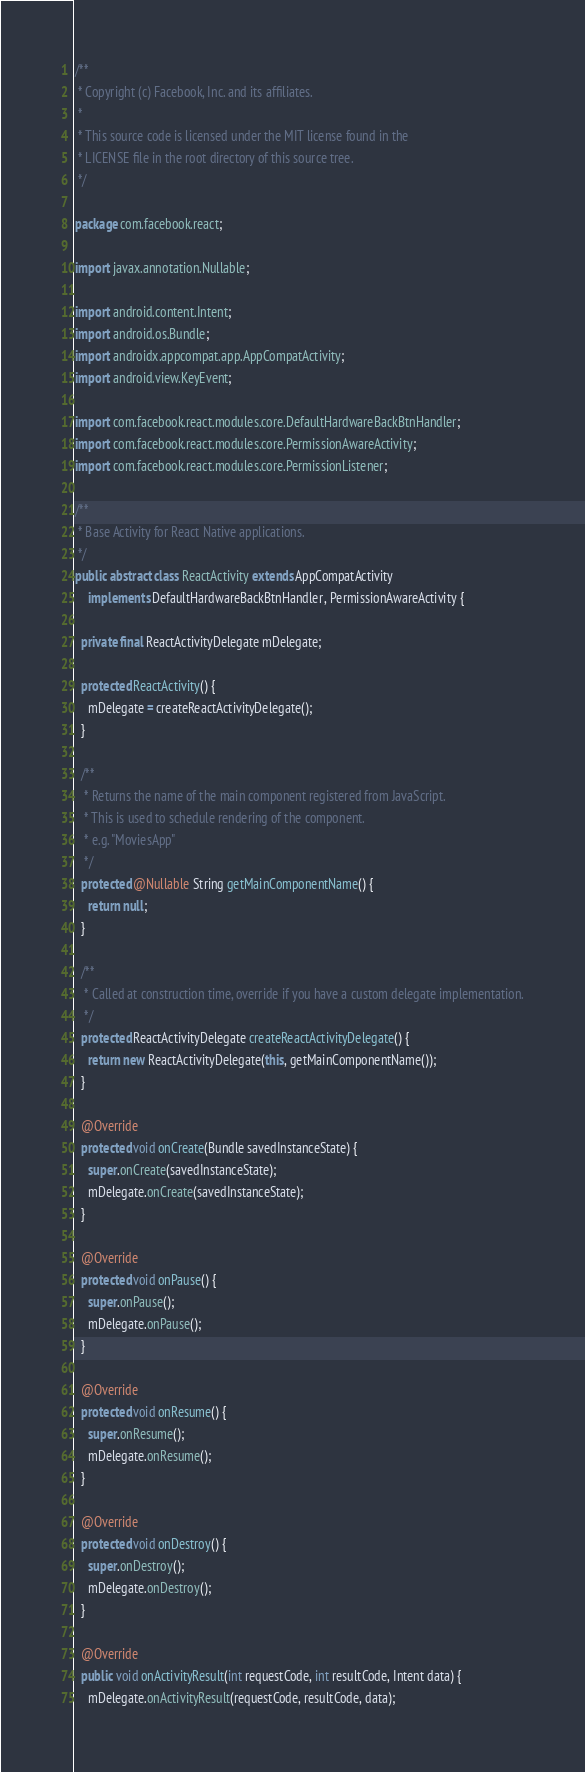<code> <loc_0><loc_0><loc_500><loc_500><_Java_>/**
 * Copyright (c) Facebook, Inc. and its affiliates.
 *
 * This source code is licensed under the MIT license found in the
 * LICENSE file in the root directory of this source tree.
 */

package com.facebook.react;

import javax.annotation.Nullable;

import android.content.Intent;
import android.os.Bundle;
import androidx.appcompat.app.AppCompatActivity;
import android.view.KeyEvent;

import com.facebook.react.modules.core.DefaultHardwareBackBtnHandler;
import com.facebook.react.modules.core.PermissionAwareActivity;
import com.facebook.react.modules.core.PermissionListener;

/**
 * Base Activity for React Native applications.
 */
public abstract class ReactActivity extends AppCompatActivity
    implements DefaultHardwareBackBtnHandler, PermissionAwareActivity {

  private final ReactActivityDelegate mDelegate;

  protected ReactActivity() {
    mDelegate = createReactActivityDelegate();
  }

  /**
   * Returns the name of the main component registered from JavaScript.
   * This is used to schedule rendering of the component.
   * e.g. "MoviesApp"
   */
  protected @Nullable String getMainComponentName() {
    return null;
  }

  /**
   * Called at construction time, override if you have a custom delegate implementation.
   */
  protected ReactActivityDelegate createReactActivityDelegate() {
    return new ReactActivityDelegate(this, getMainComponentName());
  }

  @Override
  protected void onCreate(Bundle savedInstanceState) {
    super.onCreate(savedInstanceState);
    mDelegate.onCreate(savedInstanceState);
  }

  @Override
  protected void onPause() {
    super.onPause();
    mDelegate.onPause();
  }

  @Override
  protected void onResume() {
    super.onResume();
    mDelegate.onResume();
  }

  @Override
  protected void onDestroy() {
    super.onDestroy();
    mDelegate.onDestroy();
  }

  @Override
  public void onActivityResult(int requestCode, int resultCode, Intent data) {
    mDelegate.onActivityResult(requestCode, resultCode, data);</code> 